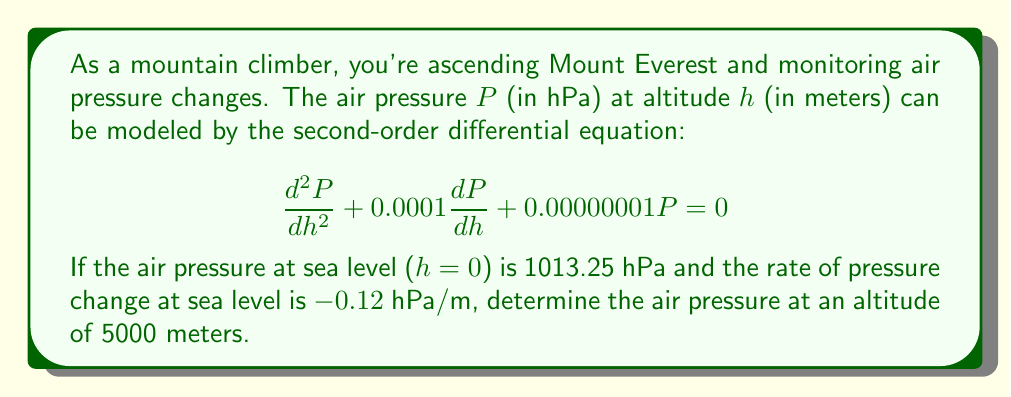Teach me how to tackle this problem. To solve this problem, we need to follow these steps:

1) First, we recognize this as a second-order linear differential equation with constant coefficients. The general solution has the form:

   $$P(h) = C_1e^{r_1h} + C_2e^{r_2h}$$

   where $r_1$ and $r_2$ are the roots of the characteristic equation.

2) The characteristic equation is:

   $$r^2 + 0.0001r + 0.00000001 = 0$$

3) Solving this quadratic equation:

   $$r = \frac{-0.0001 \pm \sqrt{0.0001^2 - 4(1)(0.00000001)}}{2(1)}$$
   $$r \approx -0.0001 \text{ or } -10^{-8}$$

4) Therefore, the general solution is:

   $$P(h) = C_1e^{-0.0001h} + C_2e^{-10^{-8}h}$$

5) Now we use the initial conditions:
   At h = 0, P = 1013.25
   At h = 0, dP/dh = -0.12

6) Applying these conditions:

   $$1013.25 = C_1 + C_2$$
   $$-0.12 = -0.0001C_1 - 10^{-8}C_2$$

7) Solving this system of equations:

   $$C_1 \approx 1013.2499$$
   $$C_2 \approx 0.0001$$

8) Our particular solution is:

   $$P(h) = 1013.2499e^{-0.0001h} + 0.0001e^{-10^{-8}h}$$

9) To find the pressure at 5000 meters, we substitute h = 5000:

   $$P(5000) = 1013.2499e^{-0.0001(5000)} + 0.0001e^{-10^{-8}(5000)}$$
   $$\approx 540.2 \text{ hPa}$$
Answer: The air pressure at an altitude of 5000 meters is approximately 540.2 hPa. 